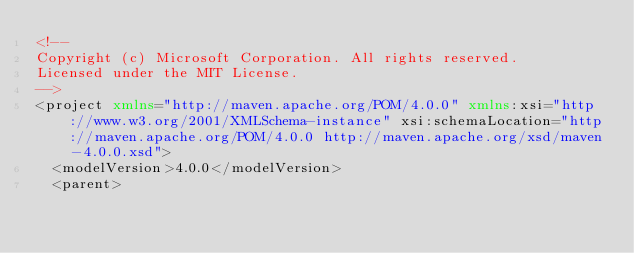<code> <loc_0><loc_0><loc_500><loc_500><_XML_><!--
Copyright (c) Microsoft Corporation. All rights reserved.
Licensed under the MIT License.
-->
<project xmlns="http://maven.apache.org/POM/4.0.0" xmlns:xsi="http://www.w3.org/2001/XMLSchema-instance" xsi:schemaLocation="http://maven.apache.org/POM/4.0.0 http://maven.apache.org/xsd/maven-4.0.0.xsd">
  <modelVersion>4.0.0</modelVersion>
  <parent></code> 